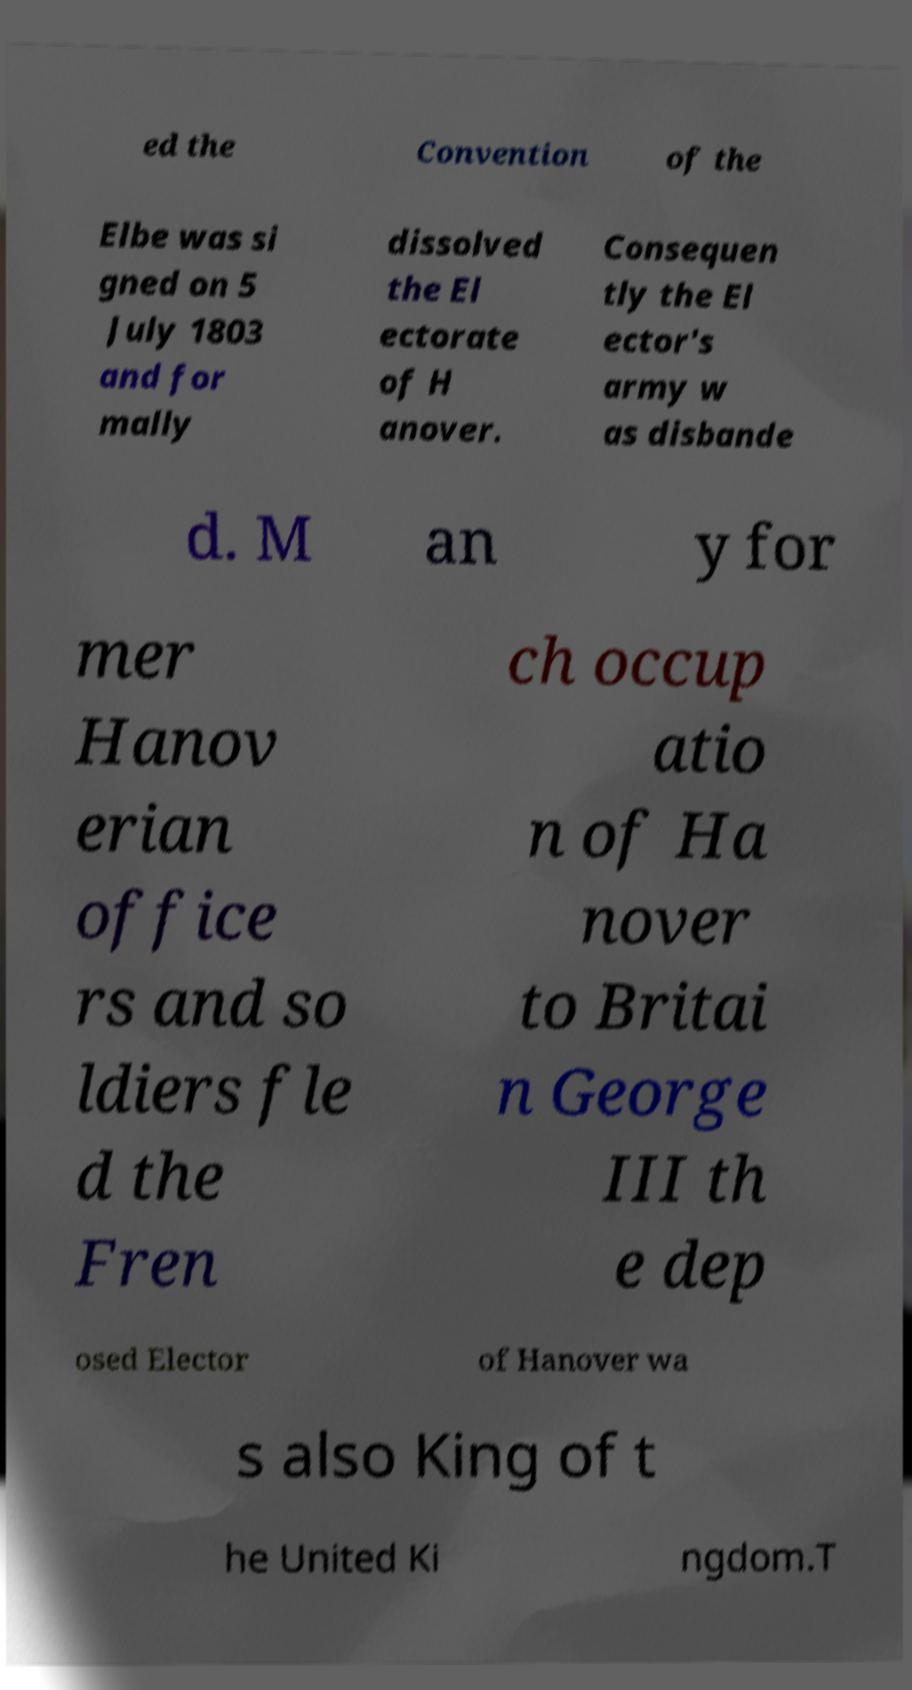Please identify and transcribe the text found in this image. ed the Convention of the Elbe was si gned on 5 July 1803 and for mally dissolved the El ectorate of H anover. Consequen tly the El ector's army w as disbande d. M an y for mer Hanov erian office rs and so ldiers fle d the Fren ch occup atio n of Ha nover to Britai n George III th e dep osed Elector of Hanover wa s also King of t he United Ki ngdom.T 